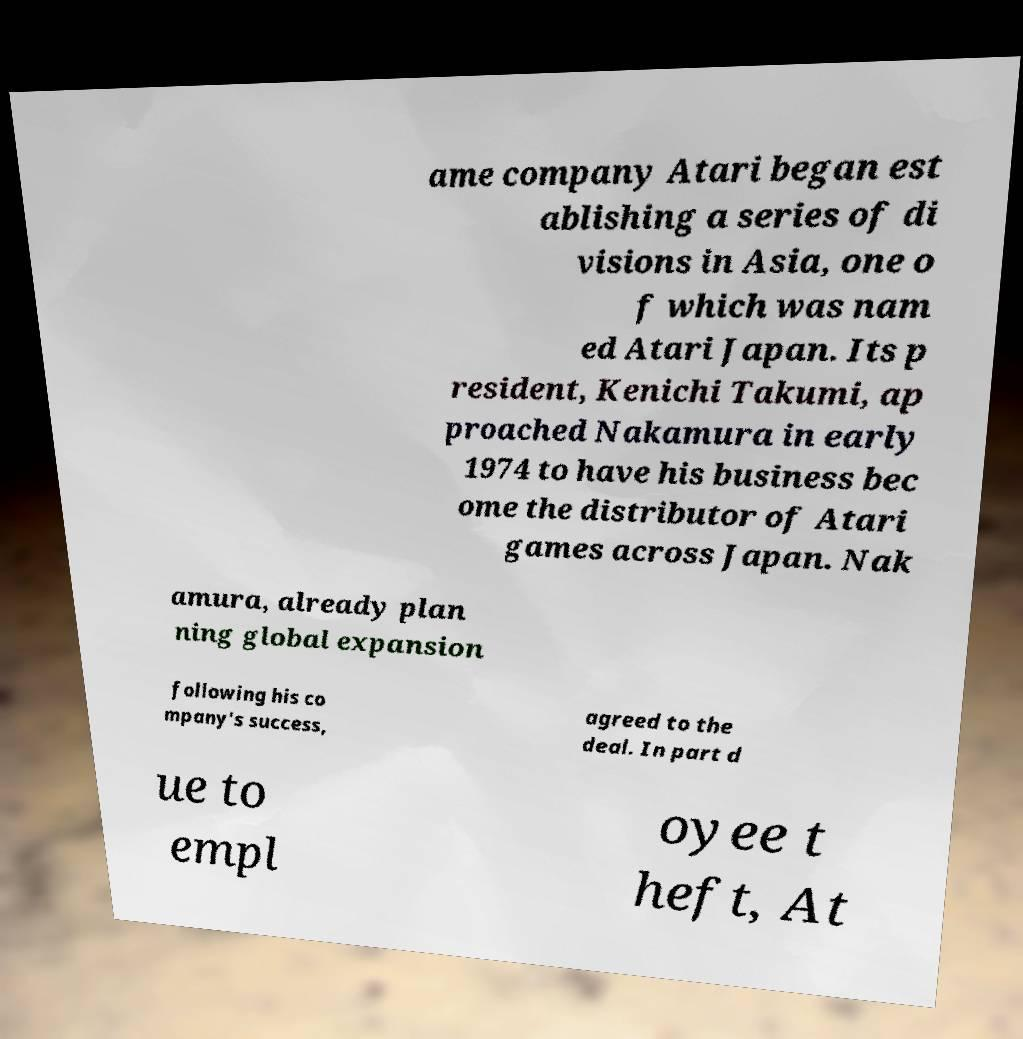What messages or text are displayed in this image? I need them in a readable, typed format. ame company Atari began est ablishing a series of di visions in Asia, one o f which was nam ed Atari Japan. Its p resident, Kenichi Takumi, ap proached Nakamura in early 1974 to have his business bec ome the distributor of Atari games across Japan. Nak amura, already plan ning global expansion following his co mpany's success, agreed to the deal. In part d ue to empl oyee t heft, At 